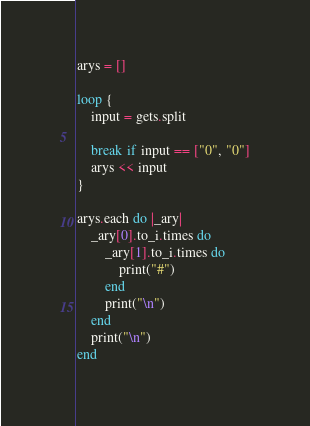Convert code to text. <code><loc_0><loc_0><loc_500><loc_500><_Ruby_>arys = []

loop {
    input = gets.split
    
    break if input == ["0", "0"]
    arys << input
}

arys.each do |_ary|
    _ary[0].to_i.times do
        _ary[1].to_i.times do
            print("#")
        end
        print("\n")
    end
    print("\n")
end

</code> 